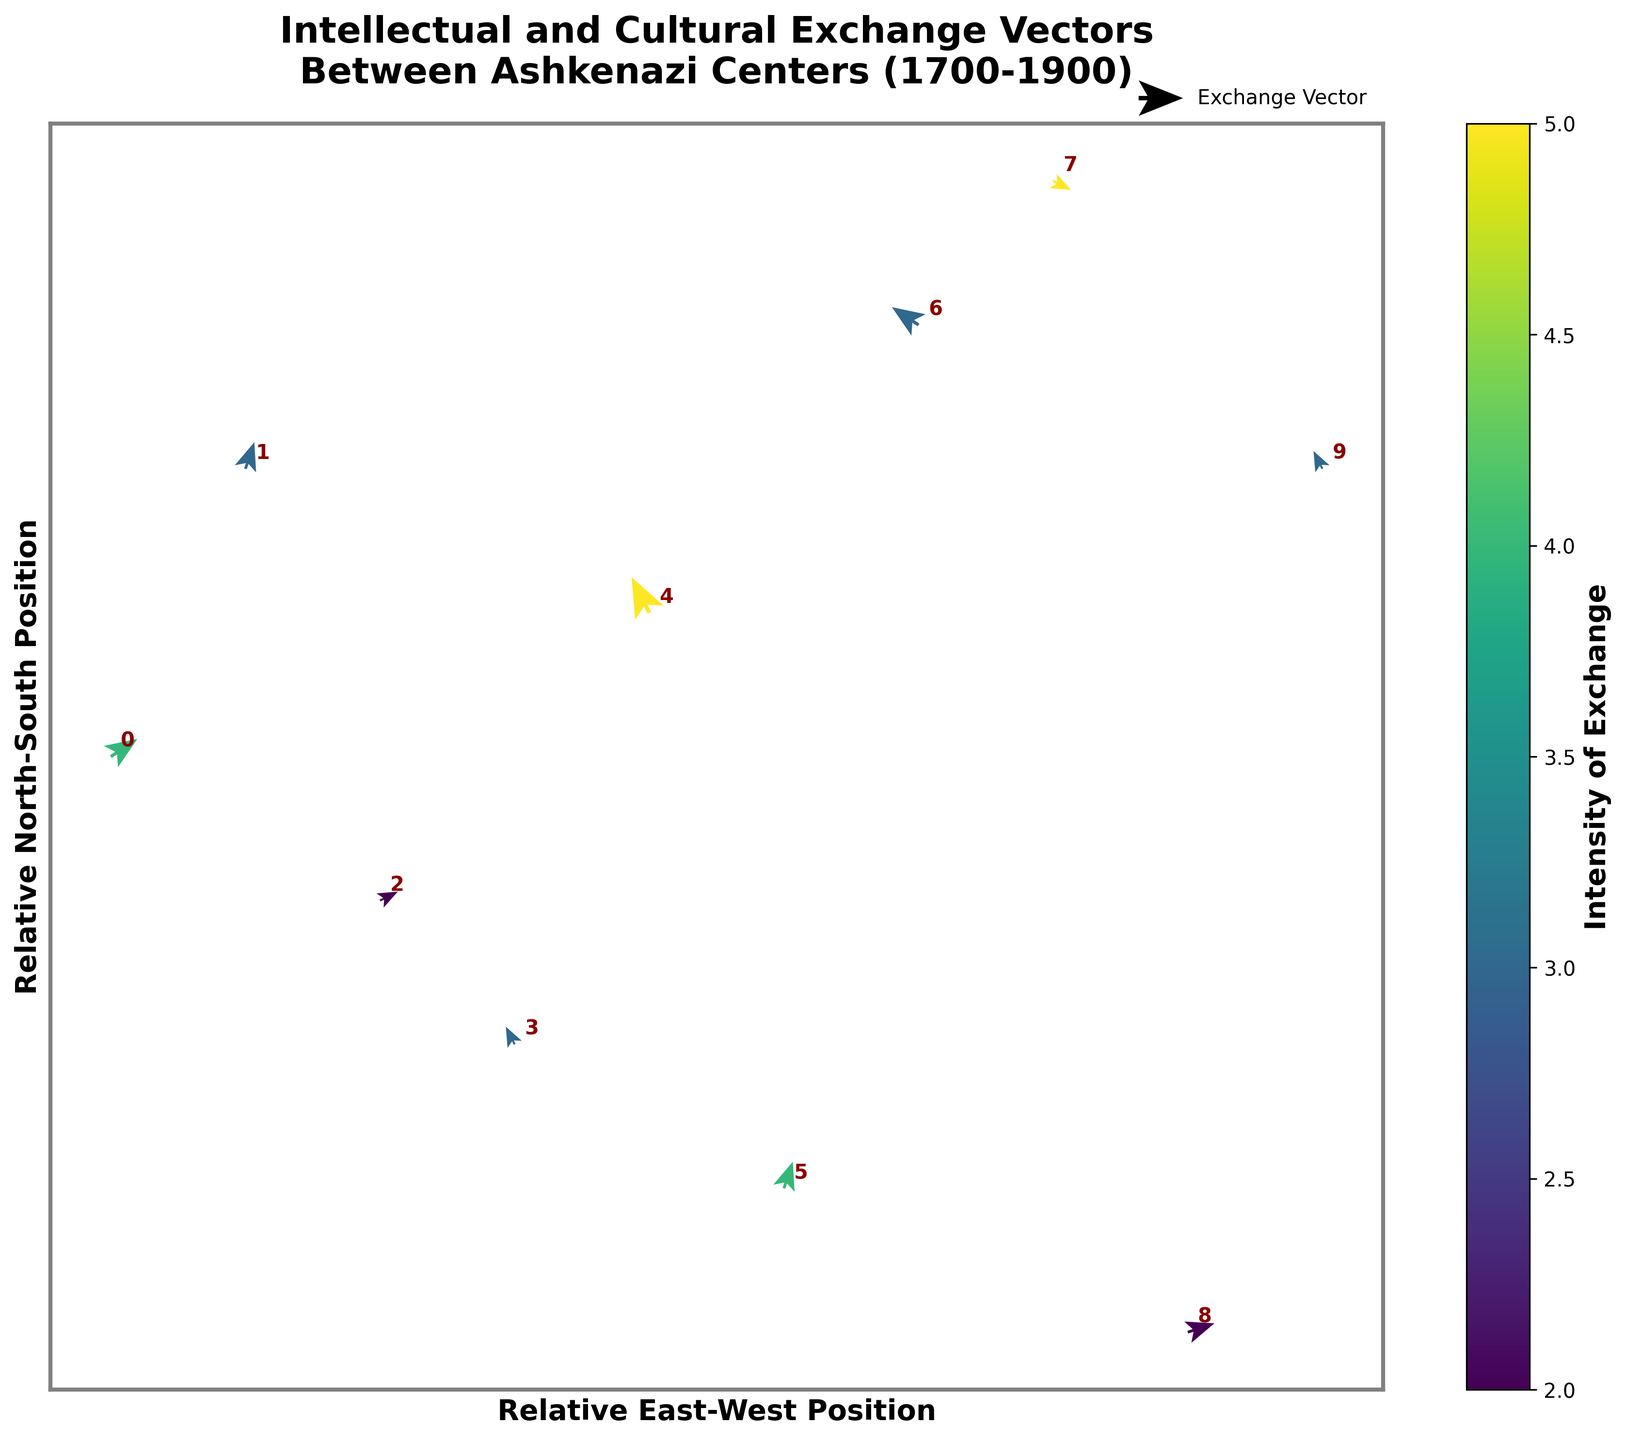What is the title of the figure? The title of a figure is typically placed at the top, providing an overview of what the figure represents. Examining the top of this plot, you can read the title directly.
Answer: Intellectual and Cultural Exchange Vectors Between Ashkenazi Centers (1700-1900) Which city has the highest intensity of intellectual exchange? Intensity can be identified by looking at the color of the vectors in the quiver plot, where a color bar guides the intensity levels. A quick examination reveals that Frankfurt and Berlin have the highest intensity, as indicated by the darkest colors on the vectors.
Answer: Frankfurt and Berlin Which city shows the most westward intellectual exchange? The direction of the vectors indicates the direction of ideas. A vector pointing left (negative x-direction) signifies westward movement. Among the displayed cities, Berlin's vector points significantly westward.
Answer: Berlin What city is located at coordinates (0.2, -0.1) and what is the direction of its vector? By finding the coordinates (0.2, -0.1) in the plot, you can identify the corresponding city. The plot annotates 'Lviv' at these coordinates, with a vector directed toward the northeast (a positive x and y direction).
Answer: Lviv, northeast How many cities have vectors pointing in a southeast direction? A southeast direction is indicated by vectors with a positive x-component and a negative y-component. Examining the plot, the cities Frankfurt, Berlin, and Budapest have such vectors.
Answer: Three Which city has both a vector magnitude greater than 0.5 and high intensity? Vector magnitude can be estimated by comparing vector lengths and checking if they are scaled above 0.5. Both Frankfurt and Berlin have vectors with approximate magnitude greater than 0.5 and exhibit high intensity.
Answer: Frankfurt and Berlin Compare the intensity of cultural exchange between Warsaw and Vilnius. Which one is higher? By examining the color of the vectors which correspond to the two cities, according to the figure, Warsaw’s vector has a darker intensity color compared to Vilnius.
Answer: Warsaw Identify two cities with vectors predominantly in the northern direction and state their intensity. A northern direction is indicated by positive y-component vectors. The cities Warsaw and Krakow have vectors with a noticeable northward direction. Checking the color key for intensity, Warsaw shows an intensity of 4, while Krakow shows 2.
Answer: Warsaw (4) and Krakow (2) Which city is closest to the origin and what is the direction of its vector? Closest to the origin refers to the coordinates nearest to (0,0). Warsaw is precisely at the origin with coordinates (0,0). The direction of its vector goes northeast.
Answer: Warsaw, northeast 